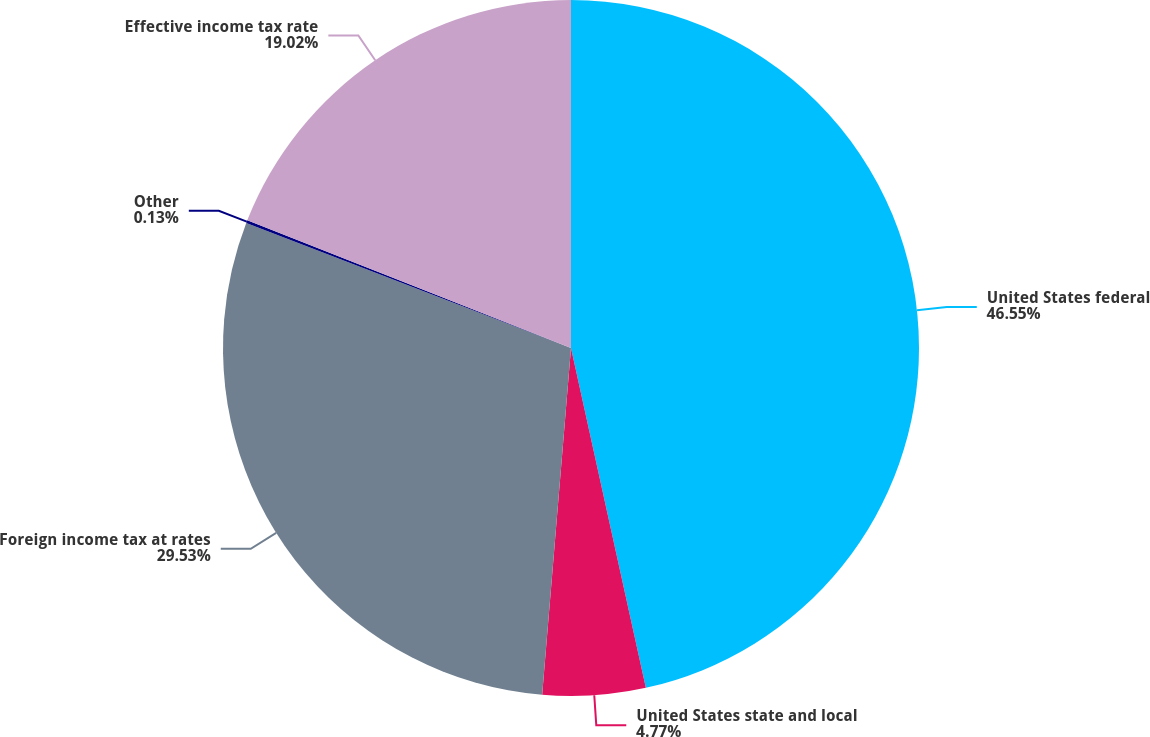<chart> <loc_0><loc_0><loc_500><loc_500><pie_chart><fcel>United States federal<fcel>United States state and local<fcel>Foreign income tax at rates<fcel>Other<fcel>Effective income tax rate<nl><fcel>46.55%<fcel>4.77%<fcel>29.53%<fcel>0.13%<fcel>19.02%<nl></chart> 